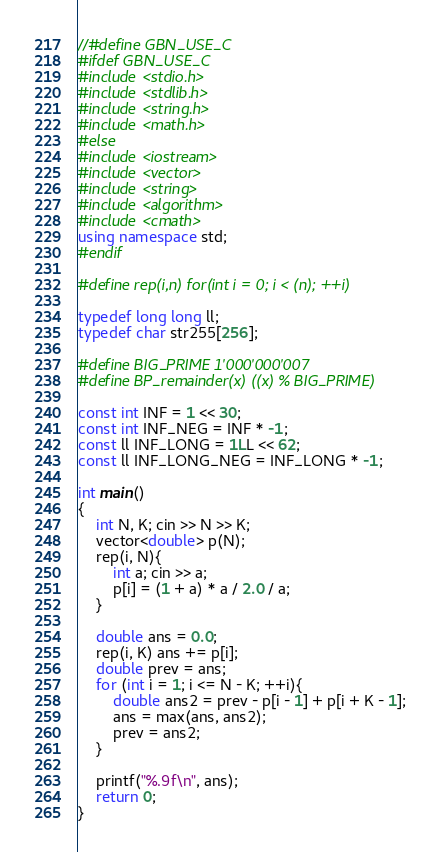Convert code to text. <code><loc_0><loc_0><loc_500><loc_500><_C++_>//#define GBN_USE_C
#ifdef GBN_USE_C
#include <stdio.h>
#include <stdlib.h>
#include <string.h>
#include <math.h>
#else
#include <iostream>
#include <vector>
#include <string>
#include <algorithm>
#include <cmath>
using namespace std;
#endif

#define rep(i,n) for(int i = 0; i < (n); ++i)
 
typedef long long ll;
typedef char str255[256];

#define BIG_PRIME 1'000'000'007
#define BP_remainder(x) ((x) % BIG_PRIME)

const int INF = 1 << 30;
const int INF_NEG = INF * -1;
const ll INF_LONG = 1LL << 62;
const ll INF_LONG_NEG = INF_LONG * -1;

int main()
{
    int N, K; cin >> N >> K;
    vector<double> p(N);
    rep(i, N){
        int a; cin >> a;
        p[i] = (1 + a) * a / 2.0 / a;
    }

    double ans = 0.0;
    rep(i, K) ans += p[i];
    double prev = ans;
    for (int i = 1; i <= N - K; ++i){
        double ans2 = prev - p[i - 1] + p[i + K - 1];
        ans = max(ans, ans2);
        prev = ans2;
    }

    printf("%.9f\n", ans);
    return 0;
}
</code> 